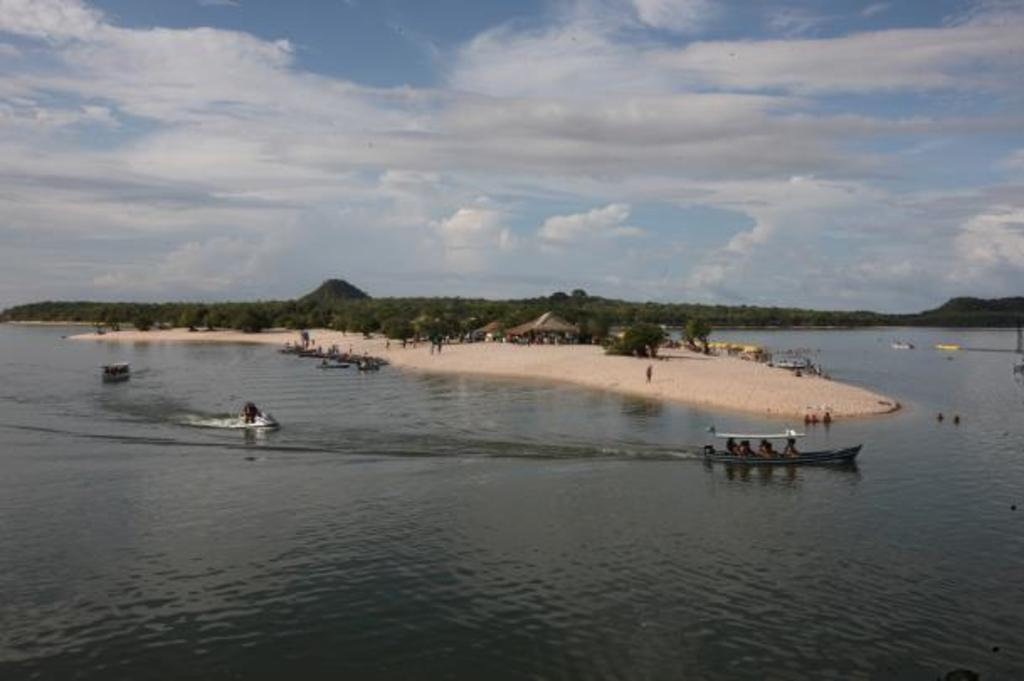Where is the image taken? The image is taken beside a road. What can be seen on the river in the image? There are boats on the river in the image. What is located in the center of the image? There is a land with people and trees in the center of the image. What features can be seen in the background of the image? Hills and the sky are visible in the background of the image. What type of hole can be seen in the image? There is no hole present in the image. What company is responsible for the boats in the image? The image does not provide information about the company responsible for the boats. 